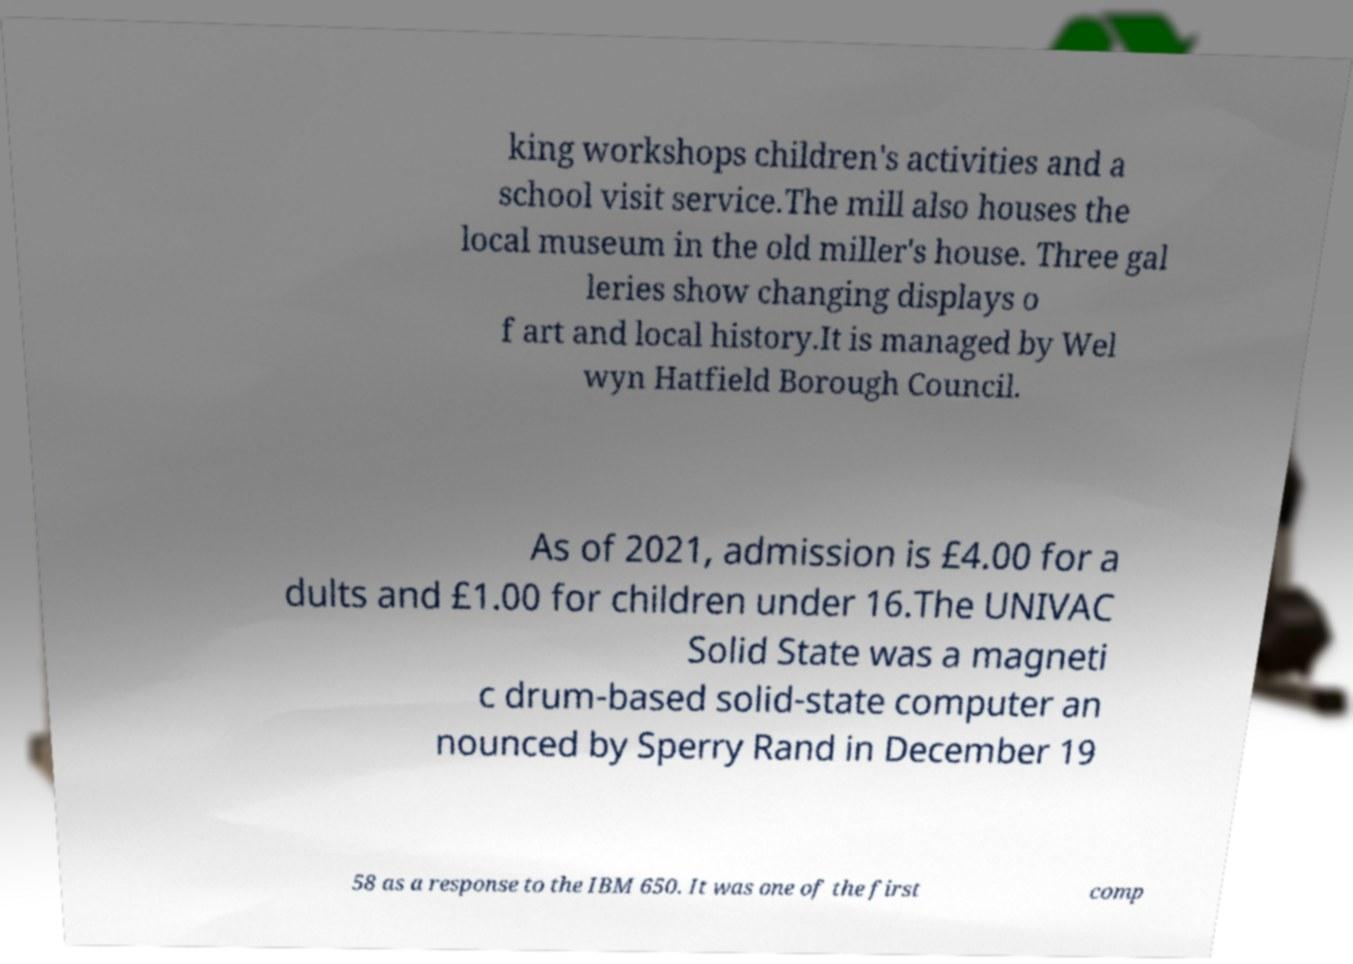Could you assist in decoding the text presented in this image and type it out clearly? king workshops children's activities and a school visit service.The mill also houses the local museum in the old miller's house. Three gal leries show changing displays o f art and local history.It is managed by Wel wyn Hatfield Borough Council. As of 2021, admission is £4.00 for a dults and £1.00 for children under 16.The UNIVAC Solid State was a magneti c drum-based solid-state computer an nounced by Sperry Rand in December 19 58 as a response to the IBM 650. It was one of the first comp 